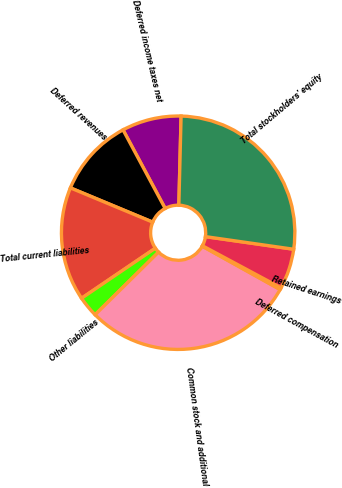Convert chart to OTSL. <chart><loc_0><loc_0><loc_500><loc_500><pie_chart><fcel>Deferred income taxes net<fcel>Deferred revenues<fcel>Total current liabilities<fcel>Other liabilities<fcel>Common stock and additional<fcel>Deferred compensation<fcel>Retained earnings<fcel>Total stockholders' equity<nl><fcel>8.23%<fcel>10.89%<fcel>15.76%<fcel>2.91%<fcel>29.51%<fcel>0.25%<fcel>5.57%<fcel>26.85%<nl></chart> 